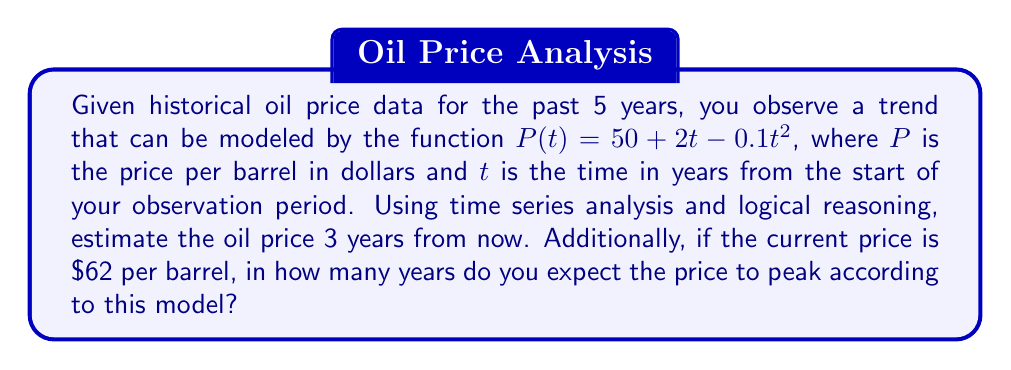Solve this math problem. To solve this problem, we'll use the given time series model and apply logical reasoning:

1. The price function is given as:
   $$P(t) = 50 + 2t - 0.1t^2$$

2. To estimate the price 3 years from now, we need to evaluate $P(8)$ since the observation period started 5 years ago:
   $$P(8) = 50 + 2(8) - 0.1(8)^2$$
   $$P(8) = 50 + 16 - 0.1(64)$$
   $$P(8) = 66 - 6.4 = 59.6$$

3. To find when the price will peak, we need to find the maximum of the quadratic function. This occurs when the derivative equals zero:
   $$\frac{dP}{dt} = 2 - 0.2t$$
   Set this equal to zero and solve for $t$:
   $$2 - 0.2t = 0$$
   $$-0.2t = -2$$
   $$t = 10$$

4. The price peaks at $t = 10$ years from the start of the observation period.

5. To find how many years from now the price will peak, we need to subtract the 5 years that have already passed:
   $$10 - 5 = 5$$ years from now

This logical analysis provides both the estimated future price and the time until the price peaks.
Answer: The estimated oil price 3 years from now is $59.60 per barrel. The price is expected to peak in 5 years from the current time. 